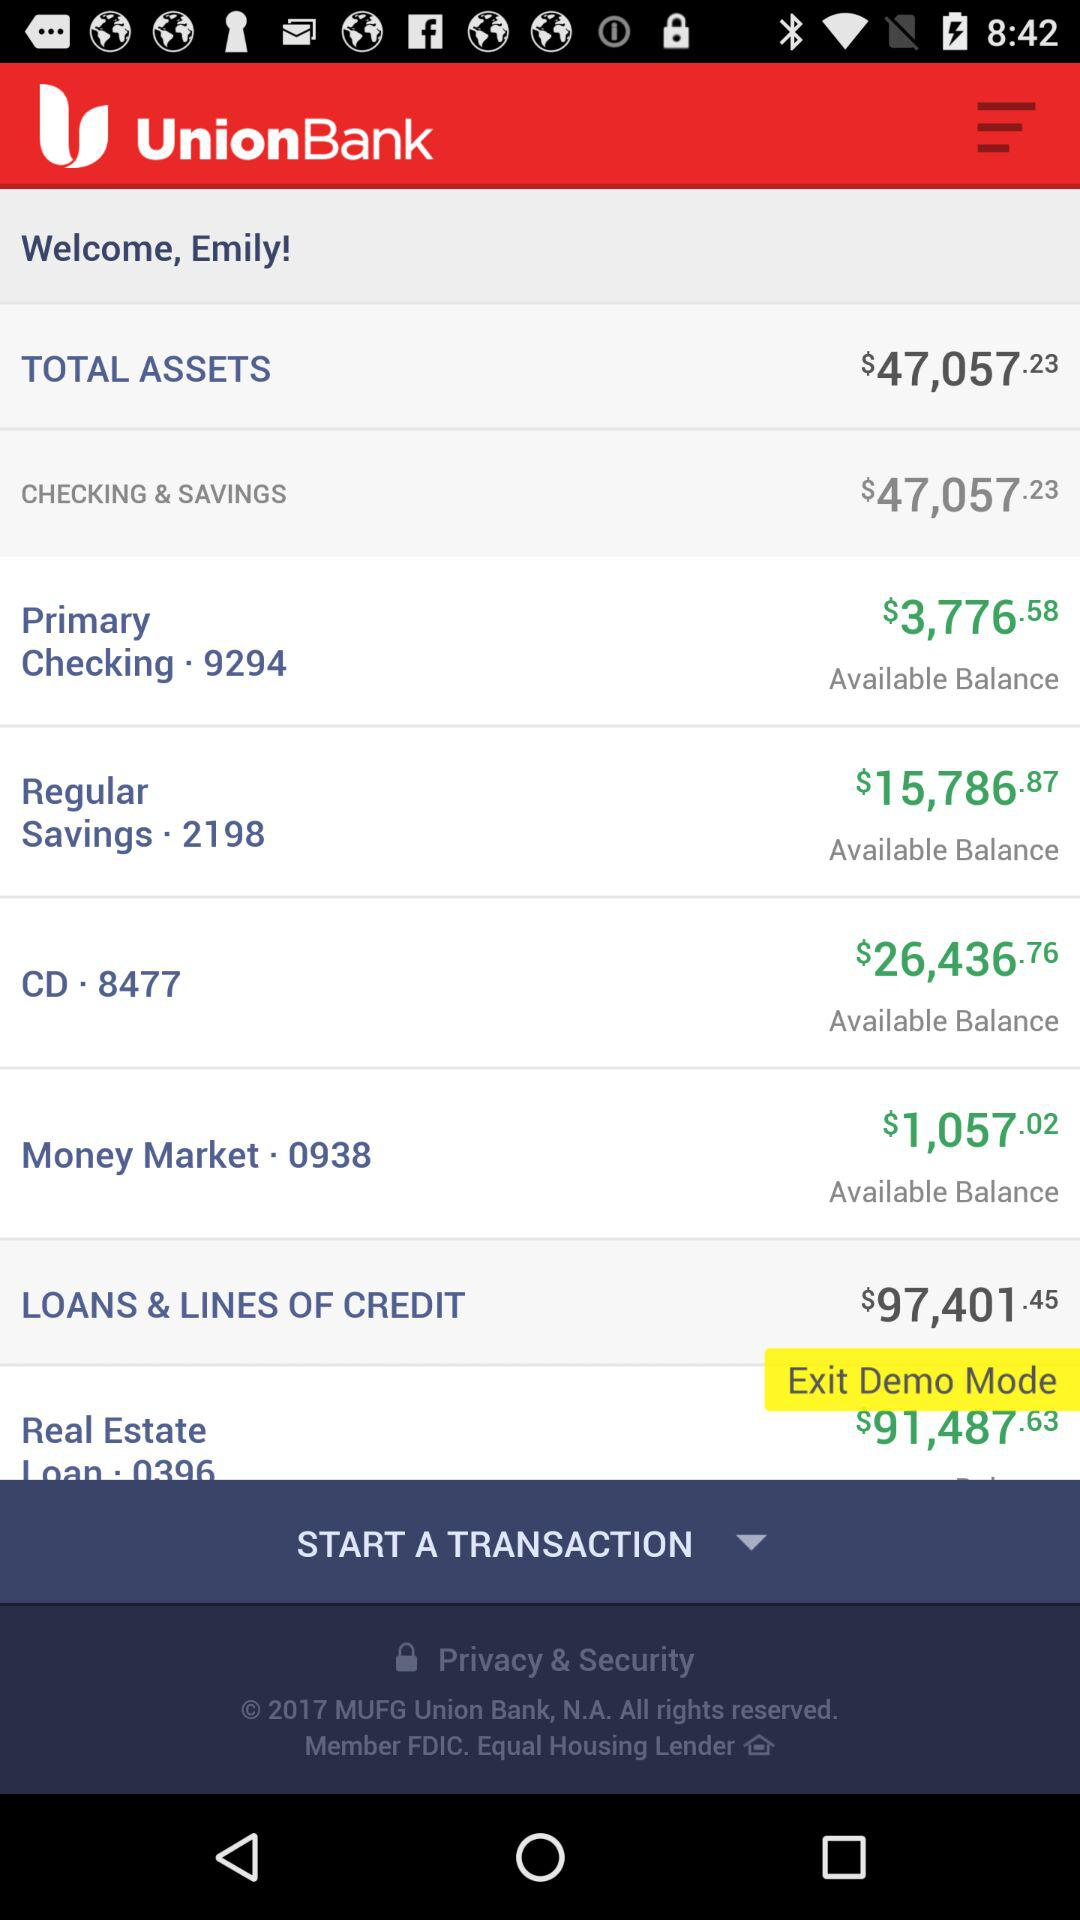What is the total balance of all checking and savings accounts?
Answer the question using a single word or phrase. $47,057.23 